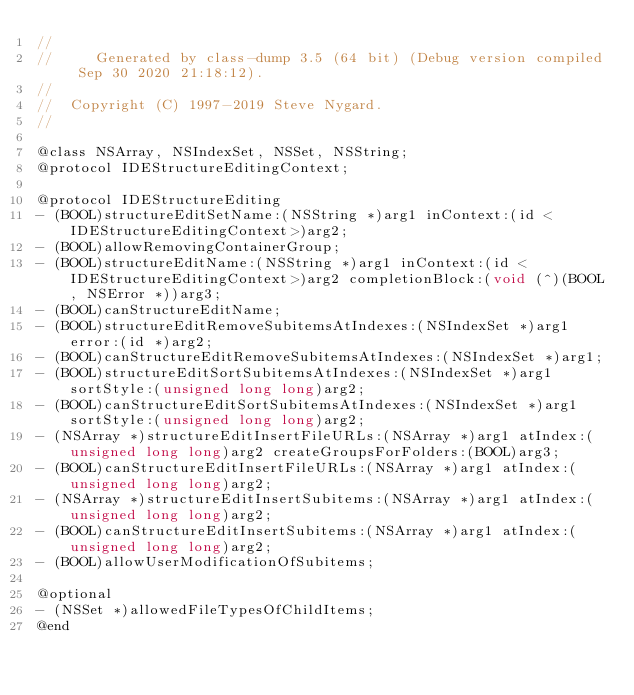<code> <loc_0><loc_0><loc_500><loc_500><_C_>//
//     Generated by class-dump 3.5 (64 bit) (Debug version compiled Sep 30 2020 21:18:12).
//
//  Copyright (C) 1997-2019 Steve Nygard.
//

@class NSArray, NSIndexSet, NSSet, NSString;
@protocol IDEStructureEditingContext;

@protocol IDEStructureEditing
- (BOOL)structureEditSetName:(NSString *)arg1 inContext:(id <IDEStructureEditingContext>)arg2;
- (BOOL)allowRemovingContainerGroup;
- (BOOL)structureEditName:(NSString *)arg1 inContext:(id <IDEStructureEditingContext>)arg2 completionBlock:(void (^)(BOOL, NSError *))arg3;
- (BOOL)canStructureEditName;
- (BOOL)structureEditRemoveSubitemsAtIndexes:(NSIndexSet *)arg1 error:(id *)arg2;
- (BOOL)canStructureEditRemoveSubitemsAtIndexes:(NSIndexSet *)arg1;
- (BOOL)structureEditSortSubitemsAtIndexes:(NSIndexSet *)arg1 sortStyle:(unsigned long long)arg2;
- (BOOL)canStructureEditSortSubitemsAtIndexes:(NSIndexSet *)arg1 sortStyle:(unsigned long long)arg2;
- (NSArray *)structureEditInsertFileURLs:(NSArray *)arg1 atIndex:(unsigned long long)arg2 createGroupsForFolders:(BOOL)arg3;
- (BOOL)canStructureEditInsertFileURLs:(NSArray *)arg1 atIndex:(unsigned long long)arg2;
- (NSArray *)structureEditInsertSubitems:(NSArray *)arg1 atIndex:(unsigned long long)arg2;
- (BOOL)canStructureEditInsertSubitems:(NSArray *)arg1 atIndex:(unsigned long long)arg2;
- (BOOL)allowUserModificationOfSubitems;

@optional
- (NSSet *)allowedFileTypesOfChildItems;
@end

</code> 